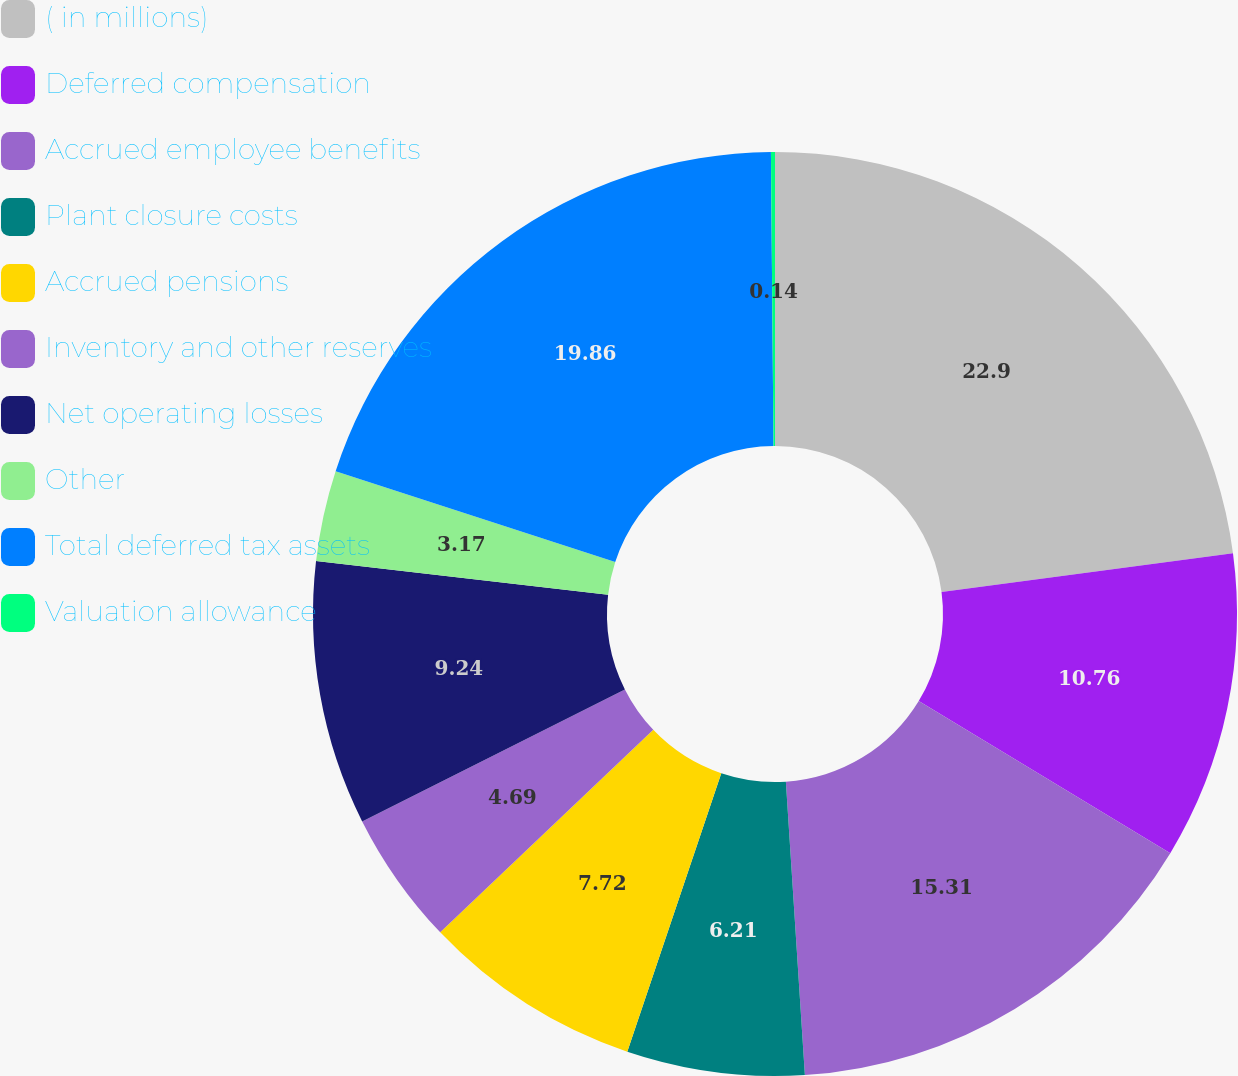<chart> <loc_0><loc_0><loc_500><loc_500><pie_chart><fcel>( in millions)<fcel>Deferred compensation<fcel>Accrued employee benefits<fcel>Plant closure costs<fcel>Accrued pensions<fcel>Inventory and other reserves<fcel>Net operating losses<fcel>Other<fcel>Total deferred tax assets<fcel>Valuation allowance<nl><fcel>22.9%<fcel>10.76%<fcel>15.31%<fcel>6.21%<fcel>7.72%<fcel>4.69%<fcel>9.24%<fcel>3.17%<fcel>19.86%<fcel>0.14%<nl></chart> 